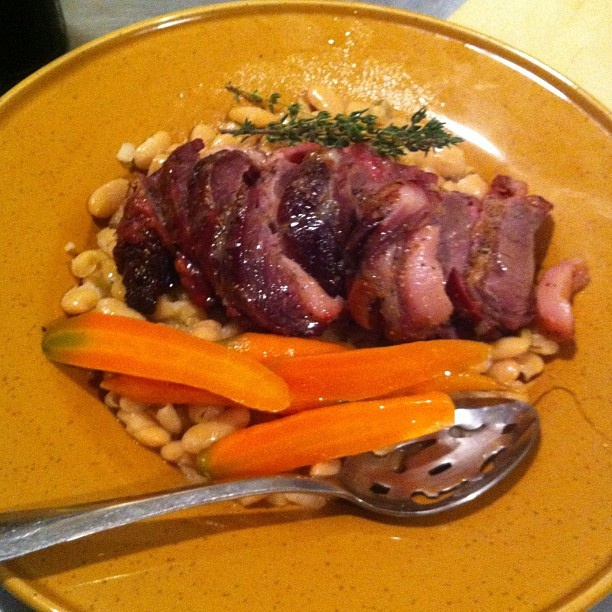Describe the objects in this image and their specific colors. I can see carrot in black, red, brown, and orange tones, spoon in black, maroon, darkgray, gray, and brown tones, and carrot in black, red, orange, and brown tones in this image. 